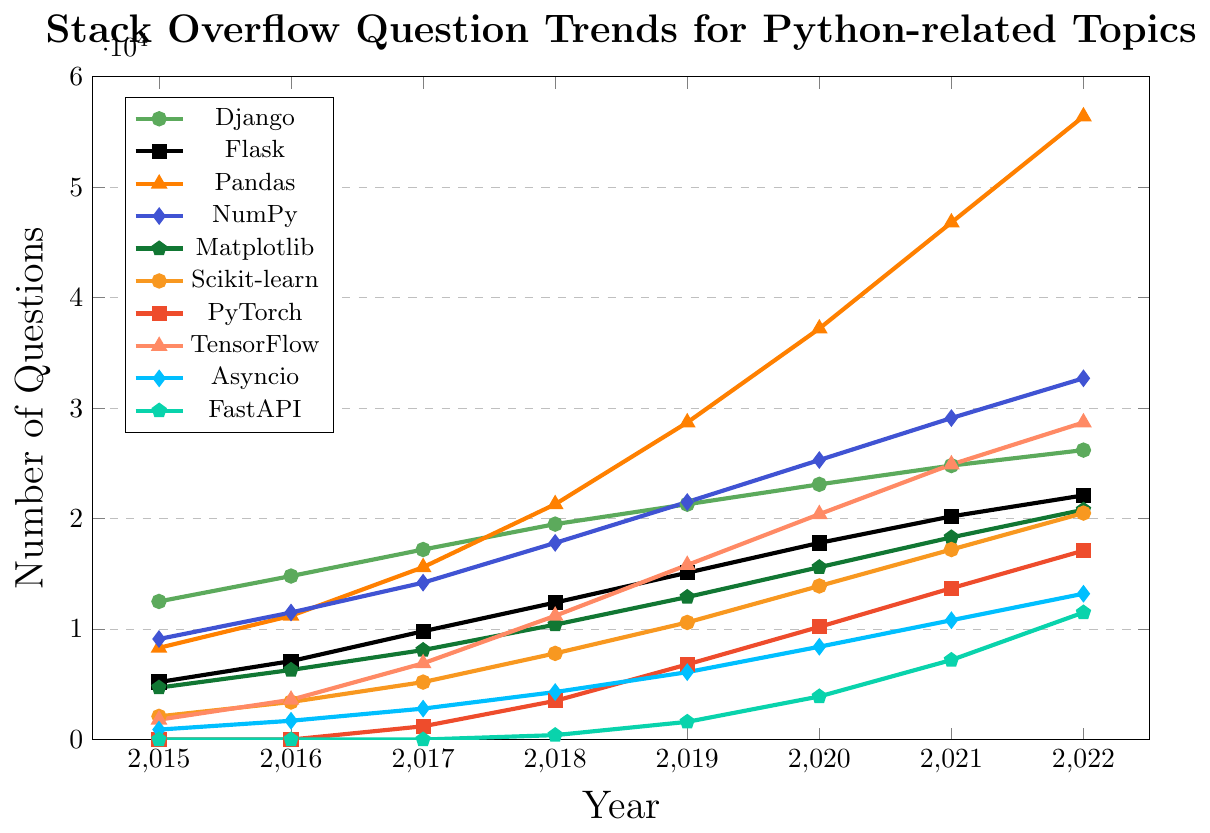How many more questions were there about Pandas than NumPy in 2022? The number of questions about Pandas in 2022 is 56400 and for NumPy is 32700. The difference is 56400 - 32700.
Answer: 23700 Between which years did the number of questions about TensorFlow see the largest increase? The increments for TensorFlow from 2015 to 2022 are as follows: 
(2016-2015): 3600-1800 = 1800,
(2017-2016): 6900-3600 = 3300,
(2018-2017): 11200-6900 = 4300,
(2019-2018): 15800-11200 = 4600,
(2020-2019): 20400-15800 = 4600,
(2021-2020): 24900-20400 = 4500,
(2022-2021): 28700-24900 = 3800. 
The largest increase is between the years 2018 and 2019 as well as 2019 and 2020, both with an increase of 4600.
Answer: 2018 and 2019, 2019 and 2020 Which topic had the highest number of questions in 2021, and how many questions were there? In 2021, the highest number of questions was for Pandas, with 46800 questions.
Answer: Pandas, 46800 What is the trend in questions for Django from 2015 to 2022? The number of questions about Django increases consistently from 12500 in 2015 to 26200 in 2022. The trend is a steady increase.
Answer: Steady increase Between which years did FastAPI start to see significant growth in the number of questions? FastAPI saw significant growth in the number of questions starting between 2019 and 2020, where the number increased from 1600 to 3900.
Answer: 2019 and 2020 How many questions were asked about Flask and Flask-related topics in 2020 and 2021 combined? Total questions for Flask in 2020 is 17800 and in 2021 is 20200. Combined, there are 17800 + 20200 = 38000 questions.
Answer: 38000 Which two topics had the same number of questions in any given year? Both TensorFlow and NumPy had 20400 questions in 2020.
Answer: TensorFlow and NumPy in 2020 What was the average number of questions for Matplotlib from 2018 to 2020? The number of questions for Matplotlib in 2018 is 10400, 2019 is 12900, and 2020 is 15600. The average is calculated as (10400 + 12900 + 15600) / 3 = 12900.
Answer: 12900 